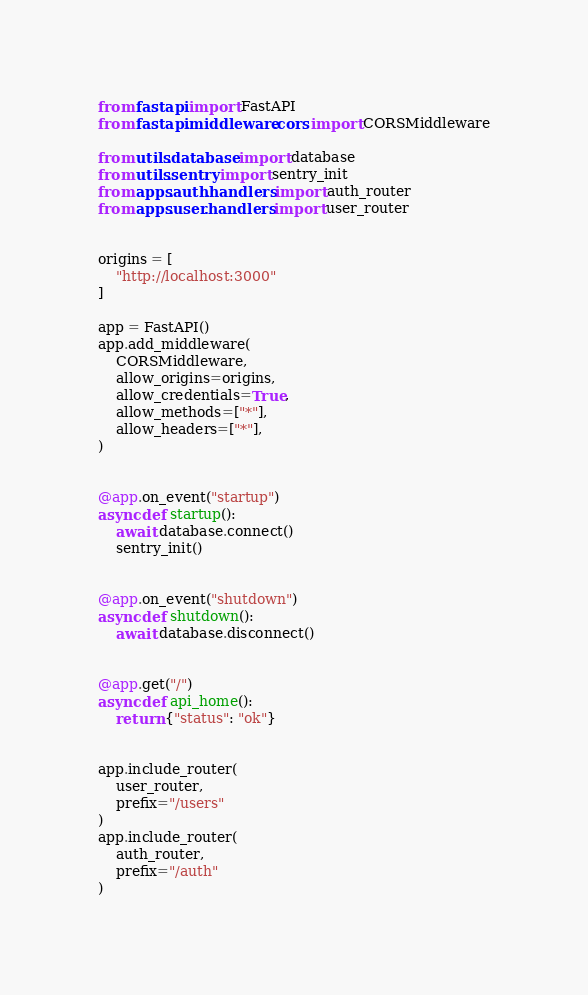<code> <loc_0><loc_0><loc_500><loc_500><_Python_>from fastapi import FastAPI
from fastapi.middleware.cors import CORSMiddleware

from utils.database import database
from utils.sentry import sentry_init
from apps.auth.handlers import auth_router
from apps.user.handlers import user_router


origins = [
    "http://localhost:3000"
]

app = FastAPI()
app.add_middleware(
    CORSMiddleware,
    allow_origins=origins,
    allow_credentials=True,
    allow_methods=["*"],
    allow_headers=["*"],
)


@app.on_event("startup")
async def startup():
    await database.connect()
    sentry_init()


@app.on_event("shutdown")
async def shutdown():
    await database.disconnect()


@app.get("/")
async def api_home():
    return {"status": "ok"}


app.include_router(
    user_router,
    prefix="/users"
)
app.include_router(
    auth_router,
    prefix="/auth"
)
</code> 